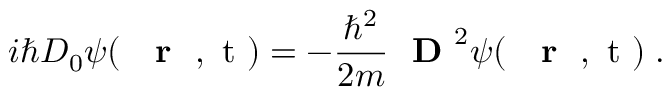Convert formula to latex. <formula><loc_0><loc_0><loc_500><loc_500>i \hbar { D } _ { 0 } \psi ( { r } , t ) = - \frac { \hbar { ^ } { 2 } } { 2 m } D ^ { 2 } \psi ( { r } , t ) \, .</formula> 